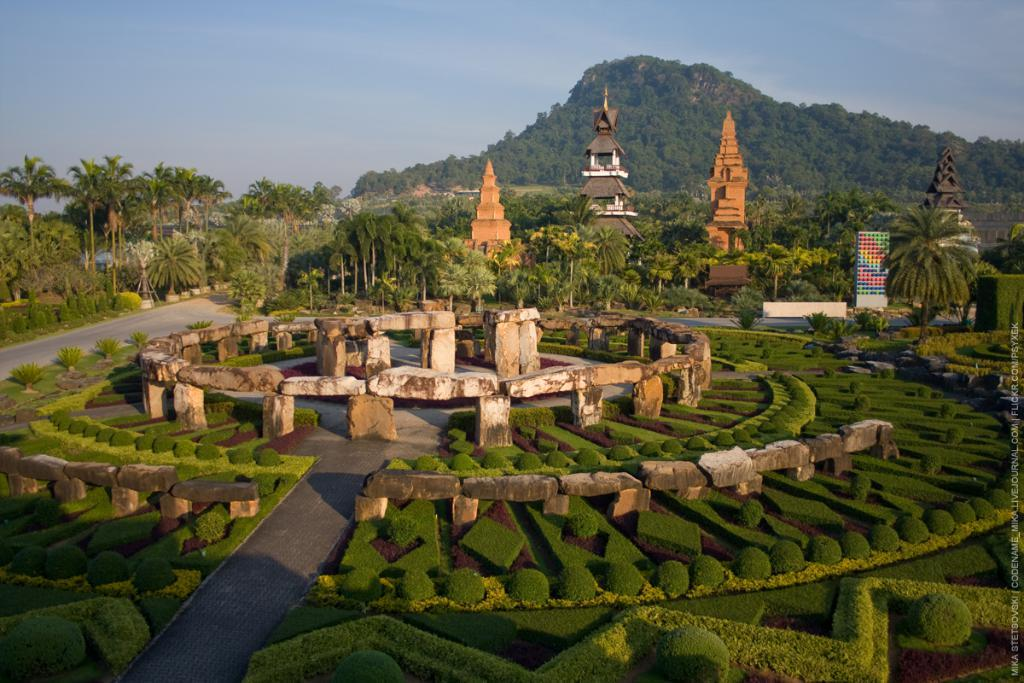What can be seen in the foreground of the image? There is a garden with plants and stones in the foreground of the image. What is visible in the background of the image? There are trees, a road, huts, mountains, and the sky visible in the background of the image. How many different types of natural elements are present in the background? There are five different types of natural elements present in the background: trees, a road, huts, mountains, and the sky. What type of grape is being used as a decoration in the garden? There is no grape present in the image, as it features a garden with plants and stones in the foreground and various natural elements in the background. How many lizards can be seen climbing on the huts in the background? There are no lizards present in the image; it features a garden with plants and stones in the foreground and various natural elements in the background. 